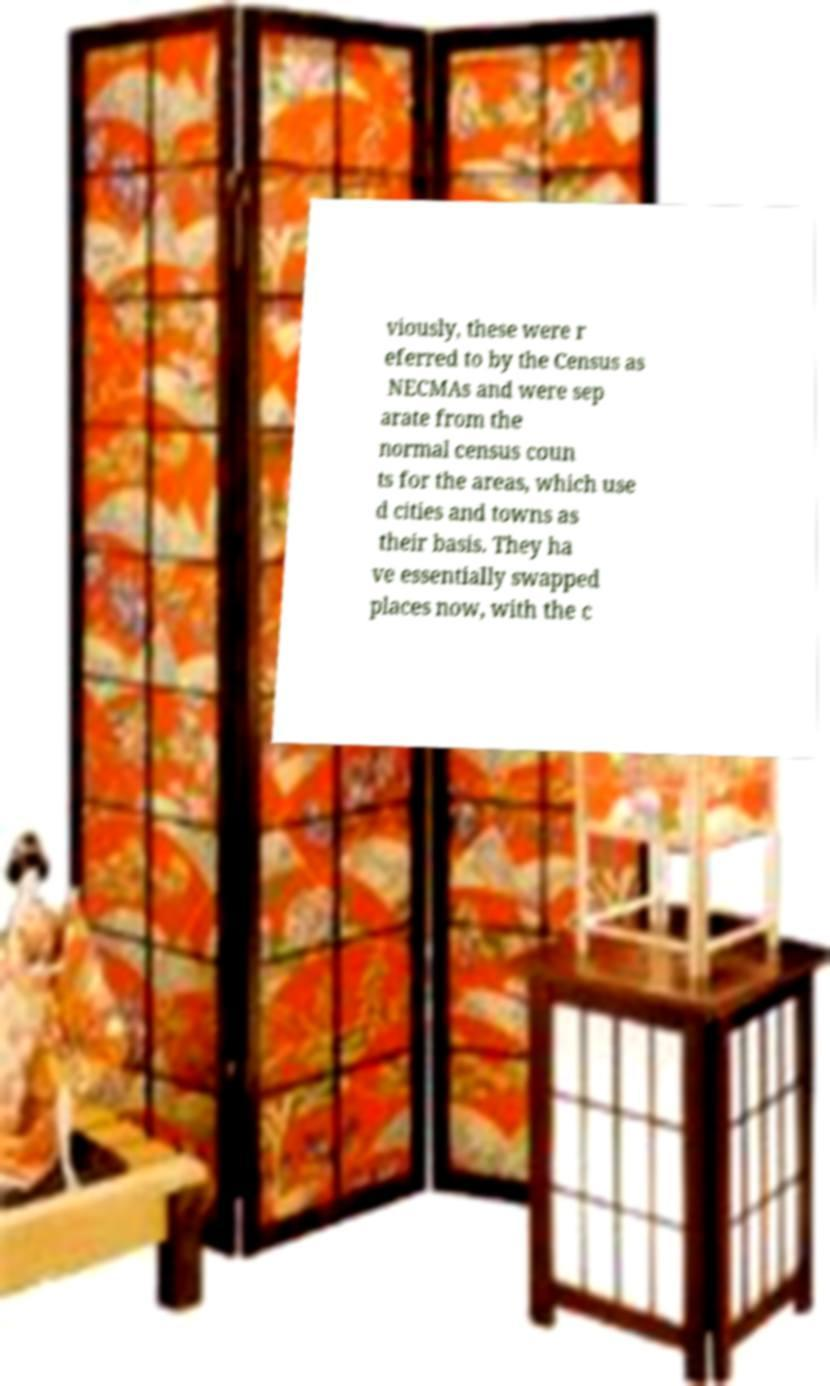For documentation purposes, I need the text within this image transcribed. Could you provide that? viously, these were r eferred to by the Census as NECMAs and were sep arate from the normal census coun ts for the areas, which use d cities and towns as their basis. They ha ve essentially swapped places now, with the c 